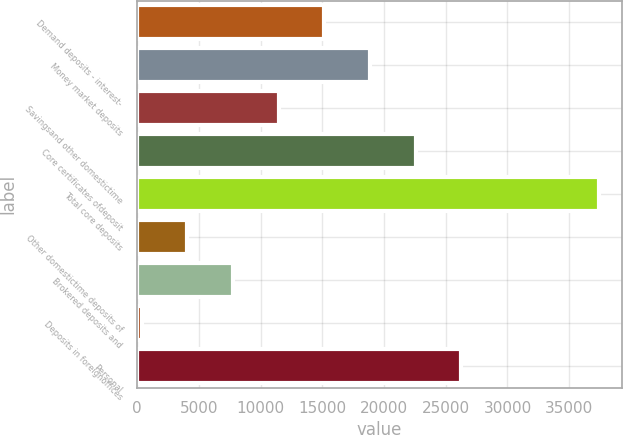Convert chart. <chart><loc_0><loc_0><loc_500><loc_500><bar_chart><fcel>Demand deposits - interest-<fcel>Money market deposits<fcel>Savingsand other domestictime<fcel>Core certificates ofdeposit<fcel>Total core deposits<fcel>Other domestictime deposits of<fcel>Brokered deposits and<fcel>Deposits in foreignoffices<fcel>Personal<nl><fcel>15169<fcel>18872<fcel>11466<fcel>22575<fcel>37387<fcel>4060<fcel>7763<fcel>357<fcel>26278<nl></chart> 